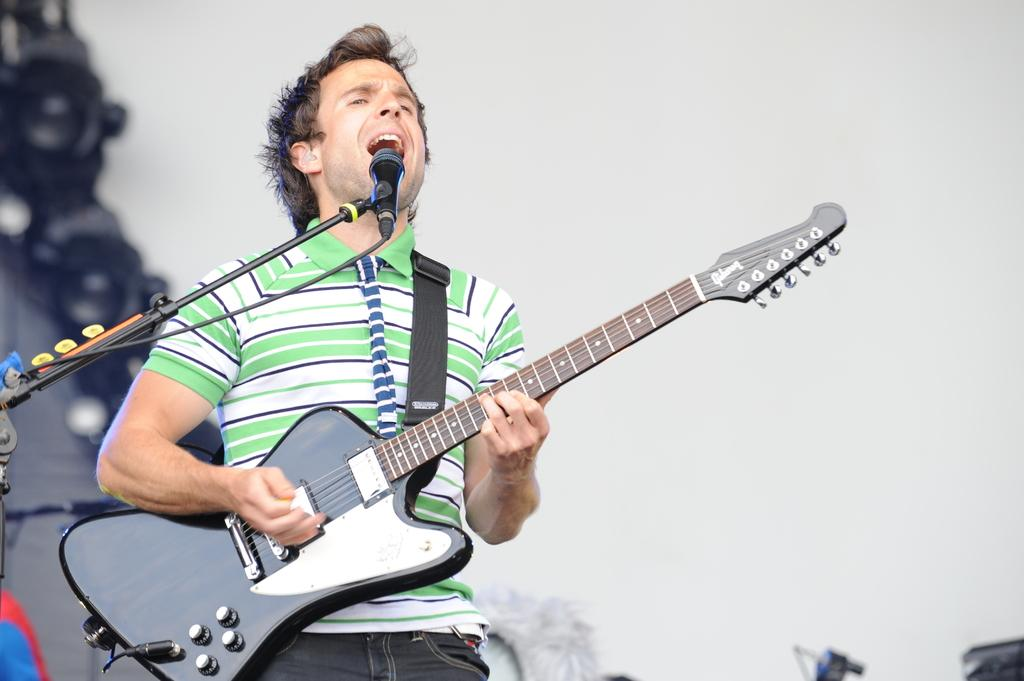What is the person in the image doing? The person is standing, playing a musical instrument, and singing a song. Can you describe the musical instrument being played? Unfortunately, the specific musical instrument cannot be identified from the provided facts. What is the person's primary activity in the image? The person's primary activity in the image is playing a musical instrument and singing a song. Can you see any goldfish swimming in the alley near the seashore in the image? There is no mention of an alley, seashore, or goldfish in the provided facts, so we cannot answer this question based on the image. 